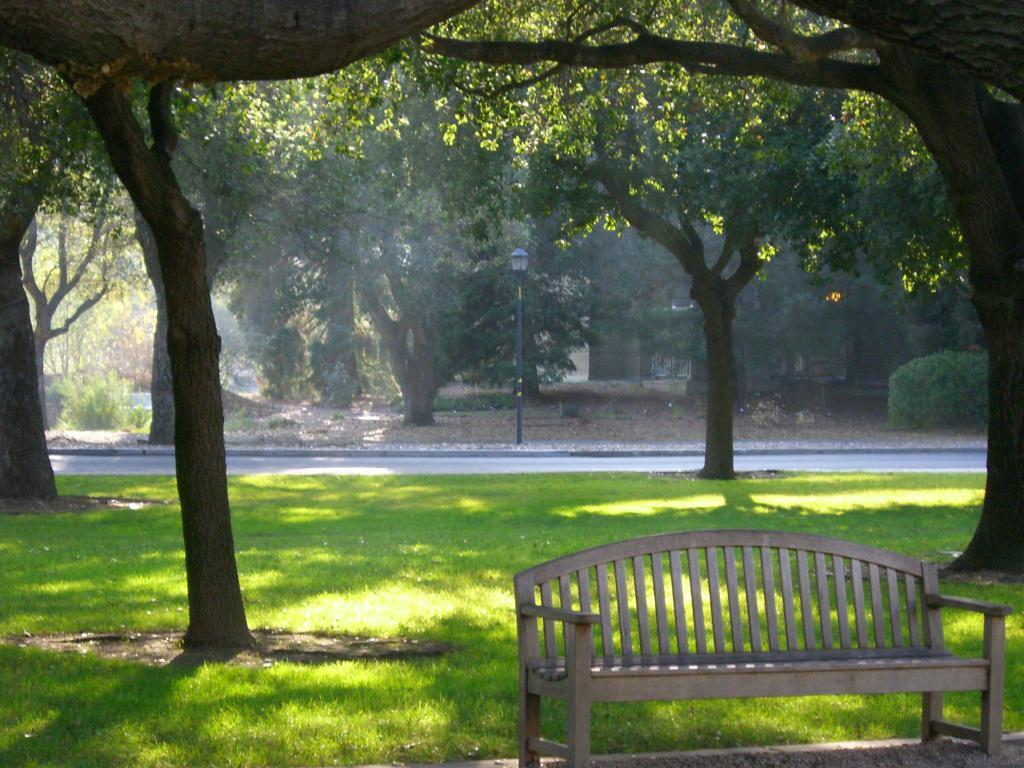What type of seating is present in the image? There is a bench in the image. What type of vegetation is visible in the image? There is grass in the image. What type of pathway is present in the image? There is a road in the image. What can be seen in the distance in the image? There are trees visible in the background of the image. What type of brush is used to clean the iron in the image? There is no brush or iron present in the image. How many things are present in the image? It is not possible to determine the exact number of things in the image, as the term "things" is too vague. However, we can identify specific objects, such as the bench, grass, road, and trees. 